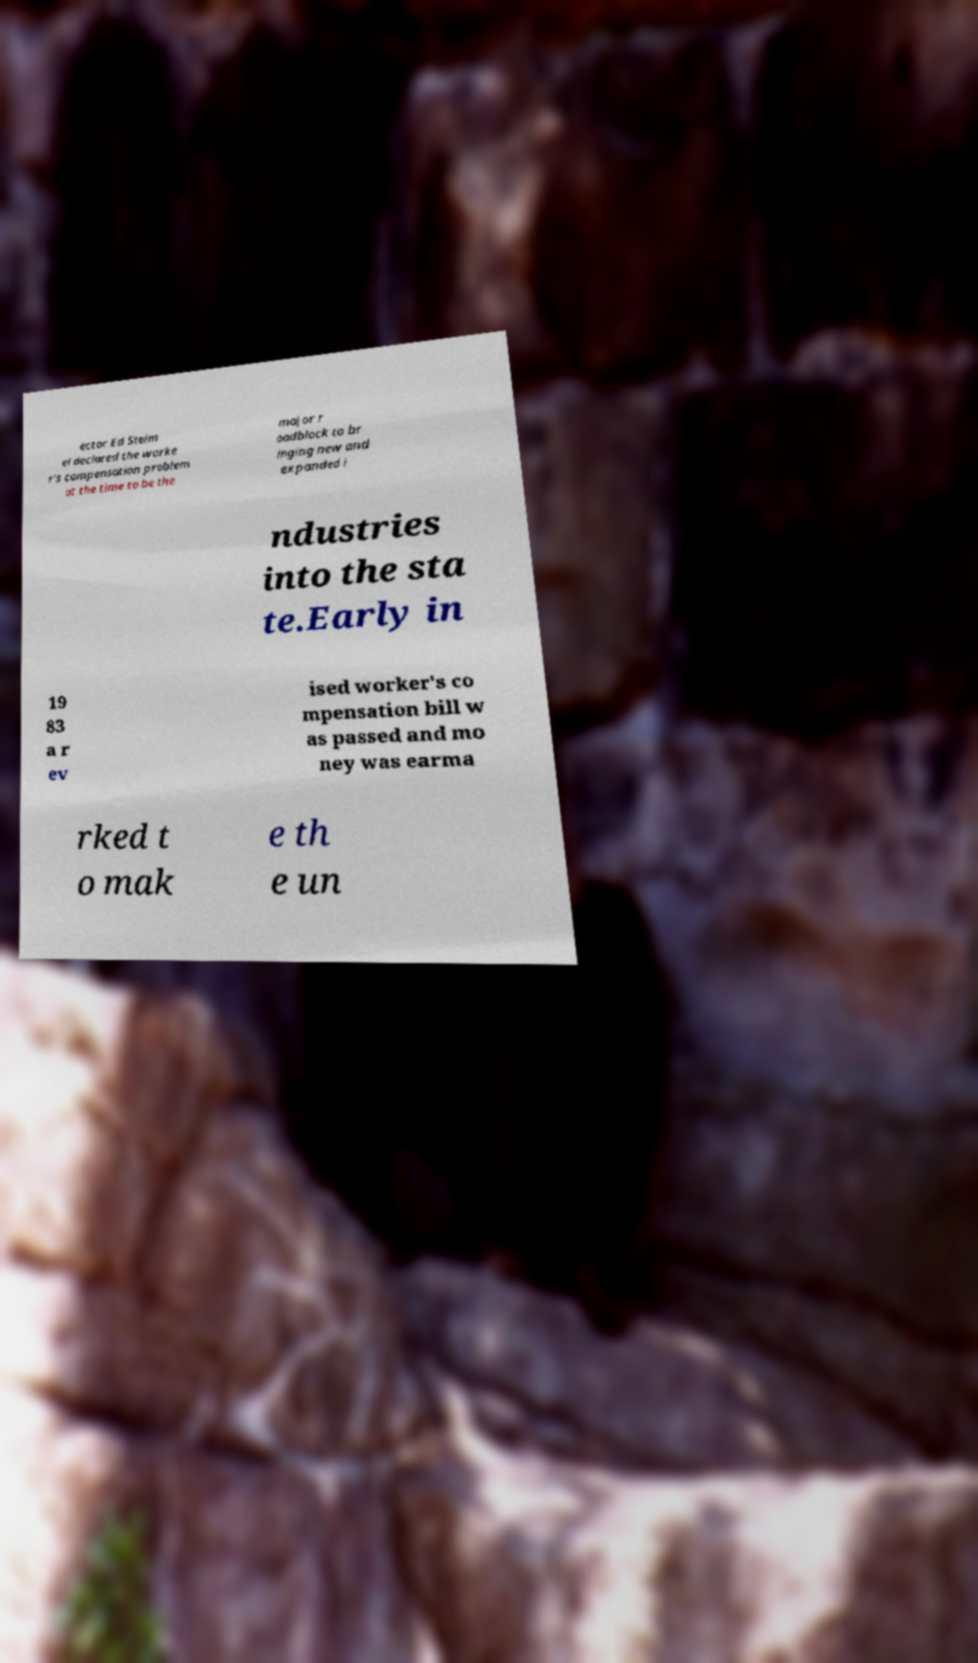There's text embedded in this image that I need extracted. Can you transcribe it verbatim? ector Ed Steim el declared the worke r's compensation problem at the time to be the major r oadblock to br inging new and expanded i ndustries into the sta te.Early in 19 83 a r ev ised worker's co mpensation bill w as passed and mo ney was earma rked t o mak e th e un 